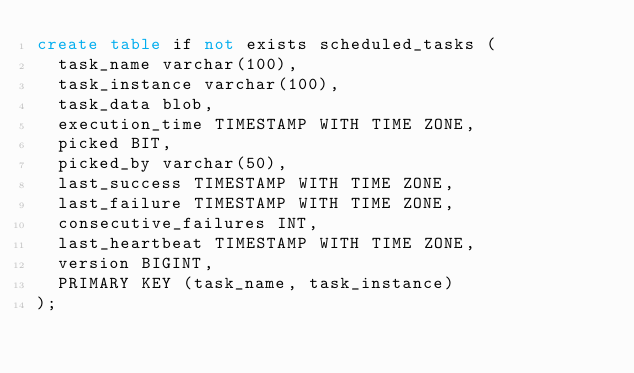Convert code to text. <code><loc_0><loc_0><loc_500><loc_500><_SQL_>create table if not exists scheduled_tasks (
	task_name varchar(100),
	task_instance varchar(100),
	task_data blob,
	execution_time TIMESTAMP WITH TIME ZONE,
	picked BIT,
	picked_by varchar(50),
	last_success TIMESTAMP WITH TIME ZONE,
	last_failure TIMESTAMP WITH TIME ZONE,
	consecutive_failures INT,
	last_heartbeat TIMESTAMP WITH TIME ZONE,
	version BIGINT,
	PRIMARY KEY (task_name, task_instance)
);
</code> 